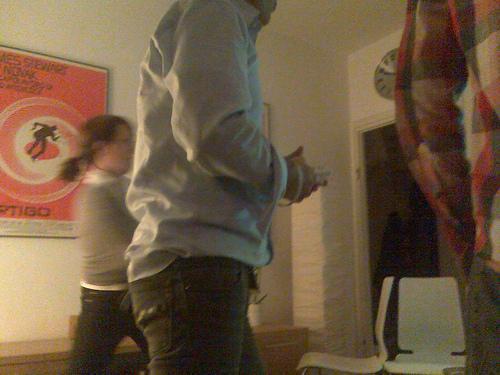How many posters are on the wall behind the woman?
Give a very brief answer. 1. 